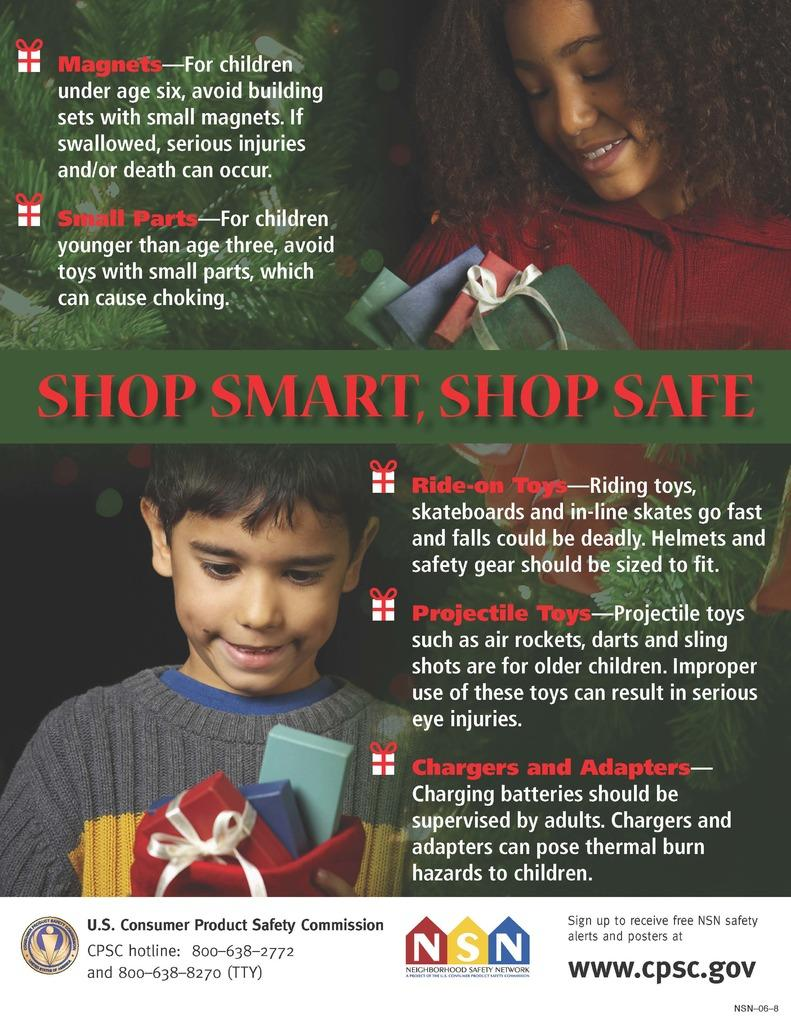What is present in the image that contains both images and text? There is a poster in the image that contains images and text. What direction is the cabbage facing in the image? There is no cabbage present in the image, so it is not possible to determine the direction it might be facing. 